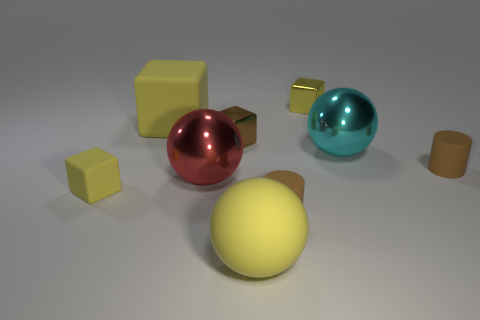Subtract all brown cylinders. How many yellow cubes are left? 3 Subtract all spheres. How many objects are left? 6 Add 6 gray matte things. How many gray matte things exist? 6 Subtract 1 brown cubes. How many objects are left? 8 Subtract all blocks. Subtract all large yellow cubes. How many objects are left? 4 Add 3 big metal spheres. How many big metal spheres are left? 5 